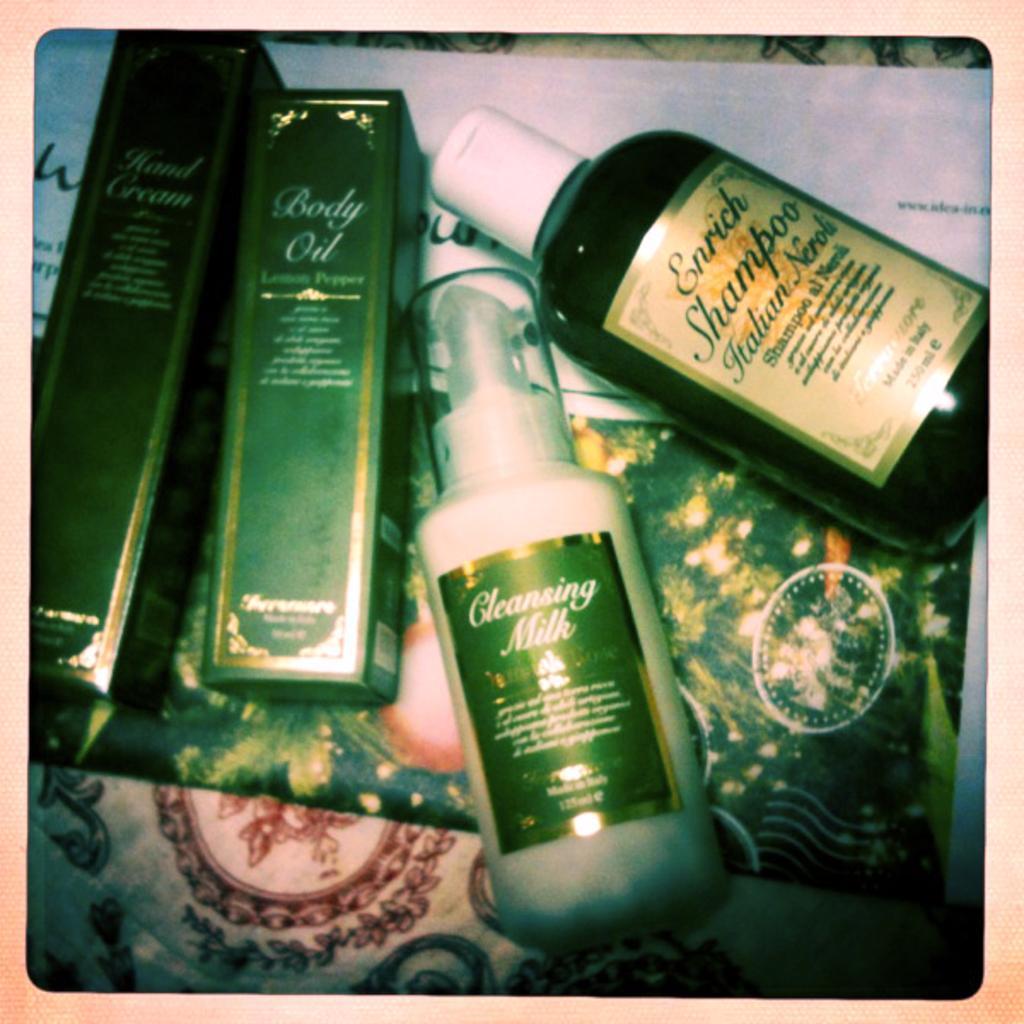Could you give a brief overview of what you see in this image? In this image, There is a table which is in white color on that table there are some bottles which are in green color kept. 